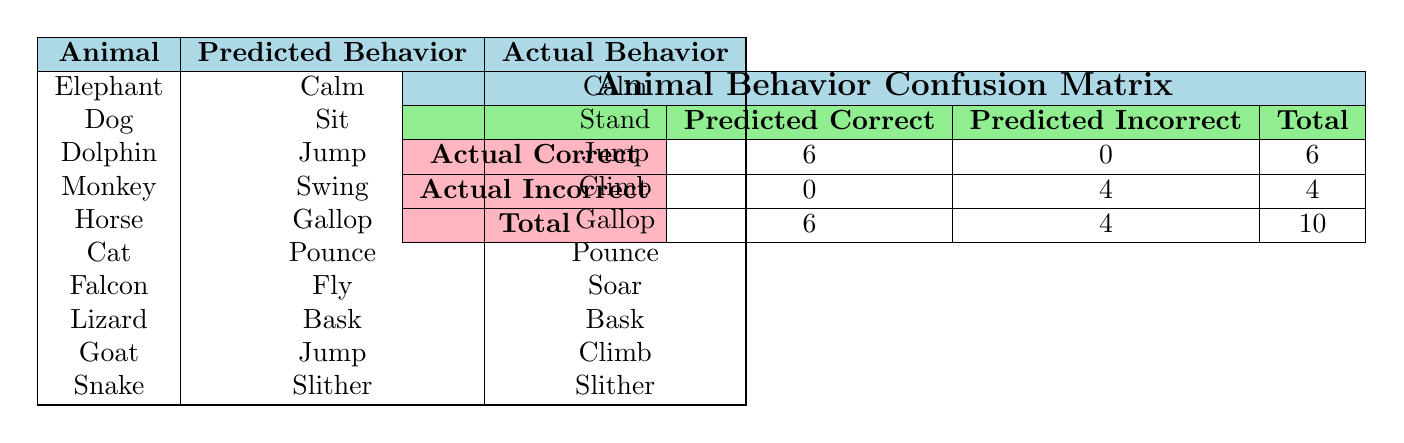What is the total number of animal behaviors assessed? The total number of animal behaviors assessed is found in the "Total" row of the confusion matrix, specifically in the last column where it states 10.
Answer: 10 How many behaviors were correctly predicted? The number of correctly predicted behaviors is found in the "Actual Correct" row under the "Predicted Correct" column, which shows 6.
Answer: 6 Which animal had a predicted behavior of "Swing"? Referring to the second table, the animal that had a predicted behavior of "Swing" is the Monkey.
Answer: Monkey What is the ratio of correct predictions to incorrect predictions? To find the ratio, we compare the number of correct predictions (6) from the "Actual Correct" row with the number of incorrect predictions (4) from the "Actual Incorrect" row. The ratio is 6:4, which simplifies to 3:2.
Answer: 3:2 Did the Dog's predicted behavior match the actual behavior? Looking at the Dog's row, the predicted behavior was "Sit," while the actual behavior was "Stand." Since these do not match, the answer is no.
Answer: No Which animal had the highest number of correct predictions? All the animals listed under "Actual Correct" column were correctly predicted (6 total), but focusing on individual animals with correct predictions, we see six of them: Elephant, Dolphin, Horse, Cat, Lizard, and Snake. Thus, all these animals had equal entries for correct predictions.
Answer: Equal entries: Elephant, Dolphin, Horse, Cat, Lizard, Snake What is the difference between predicted incorrect behaviors and actual incorrect behaviors? The "Predicted Incorrect" column shows a total of 4, while the "Actual Incorrect" row also shows a total of 4. The difference is 4 - 4 = 0.
Answer: 0 How many animals were correctly predicted but were also actually incorrect? Referring to both matrices, none of the animals fall into the category of being predicted correct yet actually incorrect because all the correctly predicted animals are listed in the "Actual Correct" row, which has zero under "Predicted Incorrect."
Answer: 0 